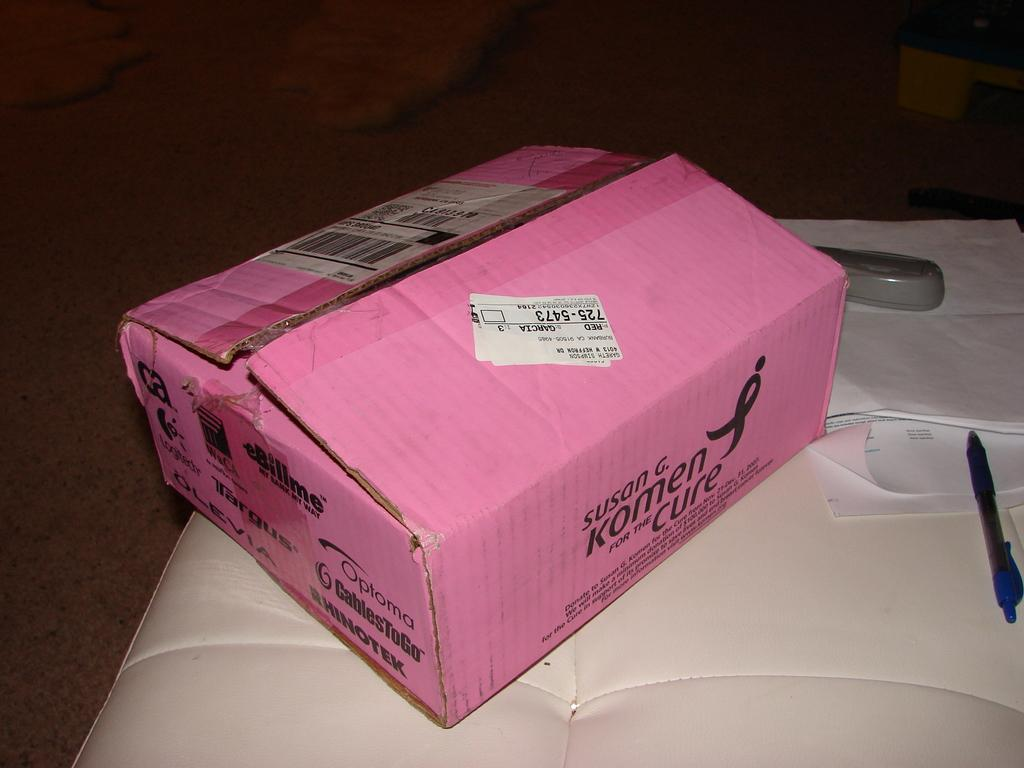<image>
Share a concise interpretation of the image provided. a pink box reading Komen for the Cure on a white top 